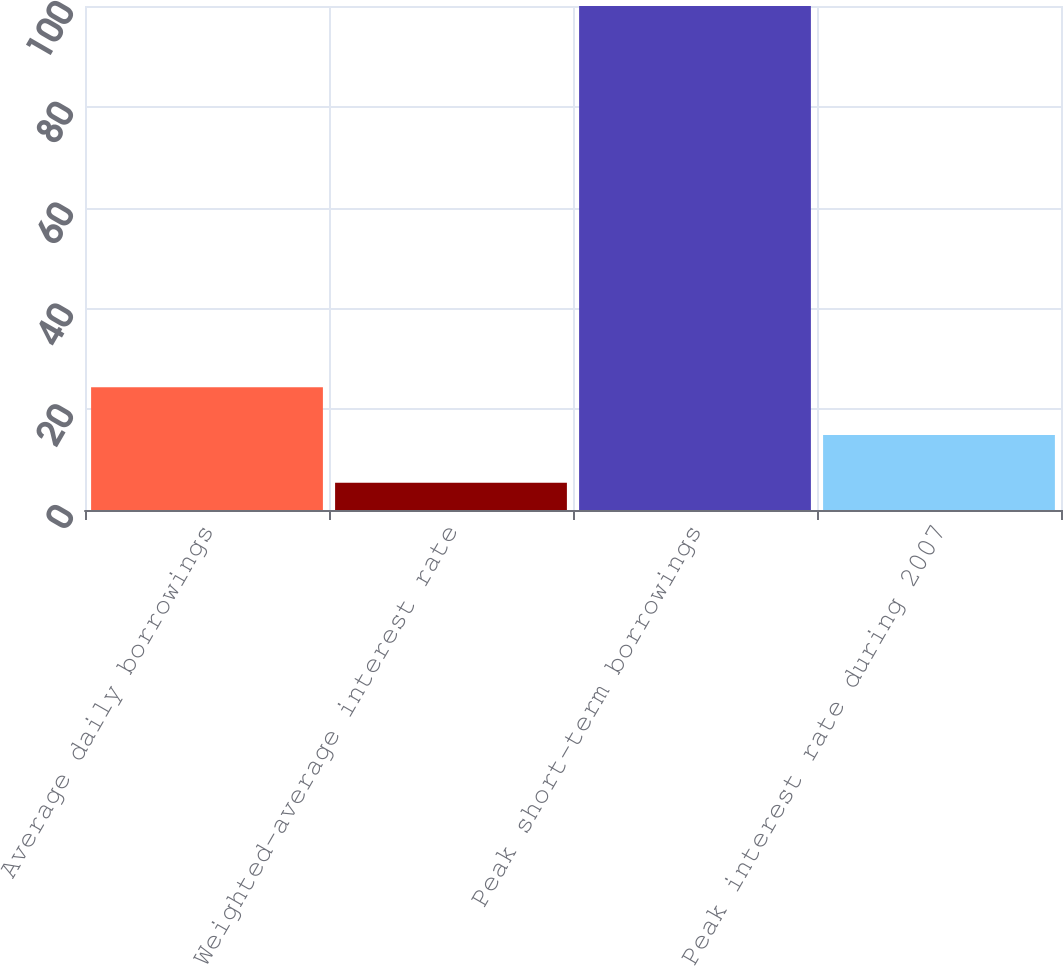Convert chart to OTSL. <chart><loc_0><loc_0><loc_500><loc_500><bar_chart><fcel>Average daily borrowings<fcel>Weighted-average interest rate<fcel>Peak short-term borrowings<fcel>Peak interest rate during 2007<nl><fcel>24.35<fcel>5.43<fcel>100<fcel>14.89<nl></chart> 